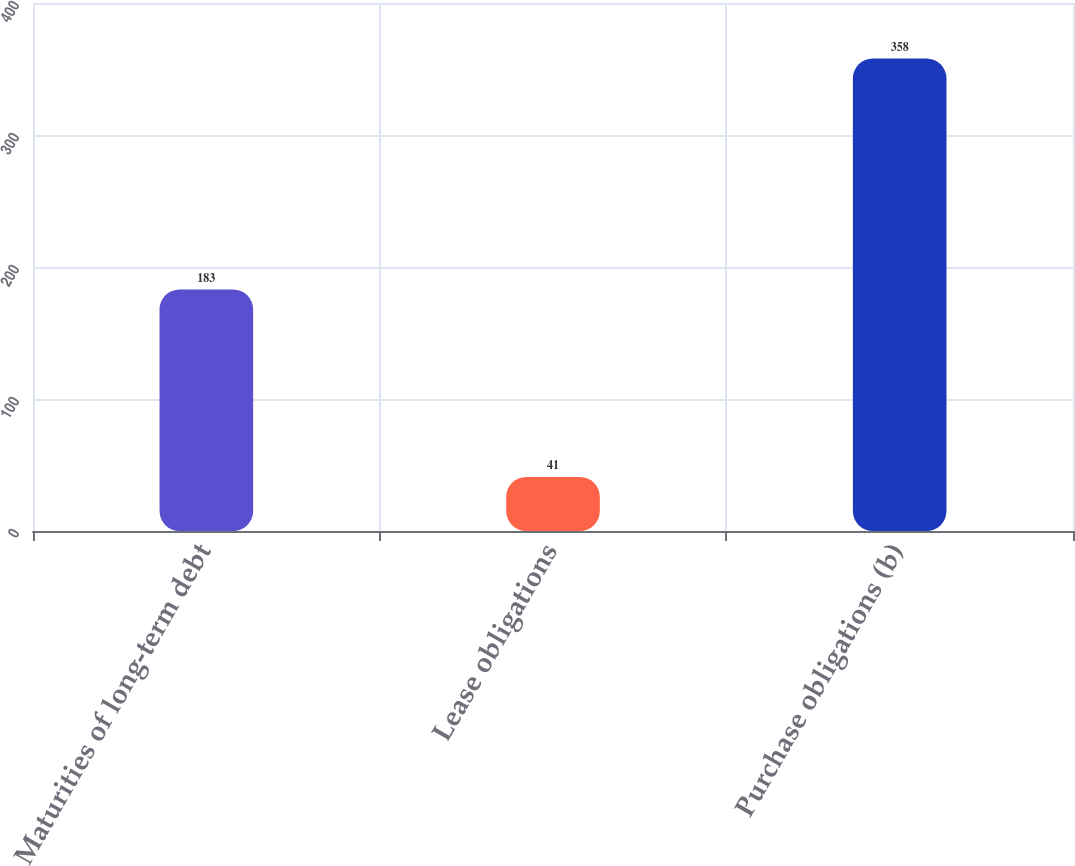Convert chart. <chart><loc_0><loc_0><loc_500><loc_500><bar_chart><fcel>Maturities of long-term debt<fcel>Lease obligations<fcel>Purchase obligations (b)<nl><fcel>183<fcel>41<fcel>358<nl></chart> 